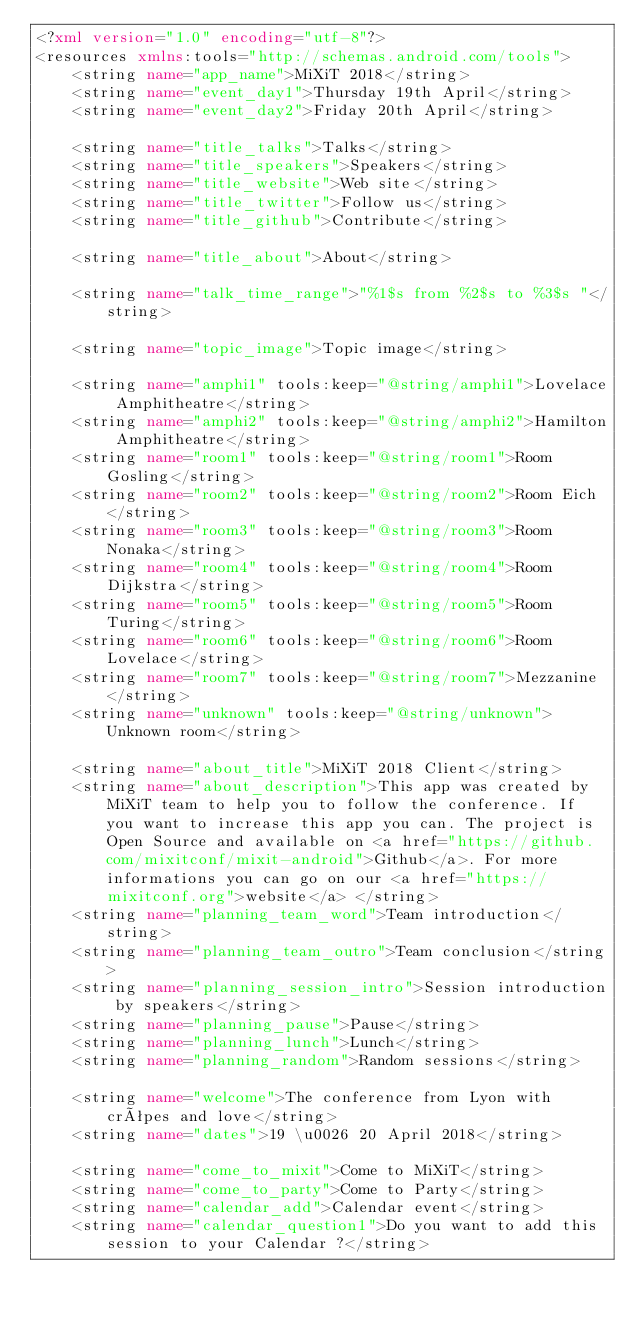Convert code to text. <code><loc_0><loc_0><loc_500><loc_500><_XML_><?xml version="1.0" encoding="utf-8"?>
<resources xmlns:tools="http://schemas.android.com/tools">
    <string name="app_name">MiXiT 2018</string>
    <string name="event_day1">Thursday 19th April</string>
    <string name="event_day2">Friday 20th April</string>

    <string name="title_talks">Talks</string>
    <string name="title_speakers">Speakers</string>
    <string name="title_website">Web site</string>
    <string name="title_twitter">Follow us</string>
    <string name="title_github">Contribute</string>

    <string name="title_about">About</string>

    <string name="talk_time_range">"%1$s from %2$s to %3$s "</string>

    <string name="topic_image">Topic image</string>

    <string name="amphi1" tools:keep="@string/amphi1">Lovelace Amphitheatre</string>
    <string name="amphi2" tools:keep="@string/amphi2">Hamilton Amphitheatre</string>
    <string name="room1" tools:keep="@string/room1">Room Gosling</string>
    <string name="room2" tools:keep="@string/room2">Room Eich</string>
    <string name="room3" tools:keep="@string/room3">Room Nonaka</string>
    <string name="room4" tools:keep="@string/room4">Room Dijkstra</string>
    <string name="room5" tools:keep="@string/room5">Room Turing</string>
    <string name="room6" tools:keep="@string/room6">Room Lovelace</string>
    <string name="room7" tools:keep="@string/room7">Mezzanine</string>
    <string name="unknown" tools:keep="@string/unknown">Unknown room</string>

    <string name="about_title">MiXiT 2018 Client</string>
    <string name="about_description">This app was created by MiXiT team to help you to follow the conference. If you want to increase this app you can. The project is Open Source and available on <a href="https://github.com/mixitconf/mixit-android">Github</a>. For more informations you can go on our <a href="https://mixitconf.org">website</a> </string>
    <string name="planning_team_word">Team introduction</string>
    <string name="planning_team_outro">Team conclusion</string>
    <string name="planning_session_intro">Session introduction by speakers</string>
    <string name="planning_pause">Pause</string>
    <string name="planning_lunch">Lunch</string>
    <string name="planning_random">Random sessions</string>

    <string name="welcome">The conference from Lyon with crêpes and love</string>
    <string name="dates">19 \u0026 20 April 2018</string>

    <string name="come_to_mixit">Come to MiXiT</string>
    <string name="come_to_party">Come to Party</string>
    <string name="calendar_add">Calendar event</string>
    <string name="calendar_question1">Do you want to add this session to your Calendar ?</string></code> 